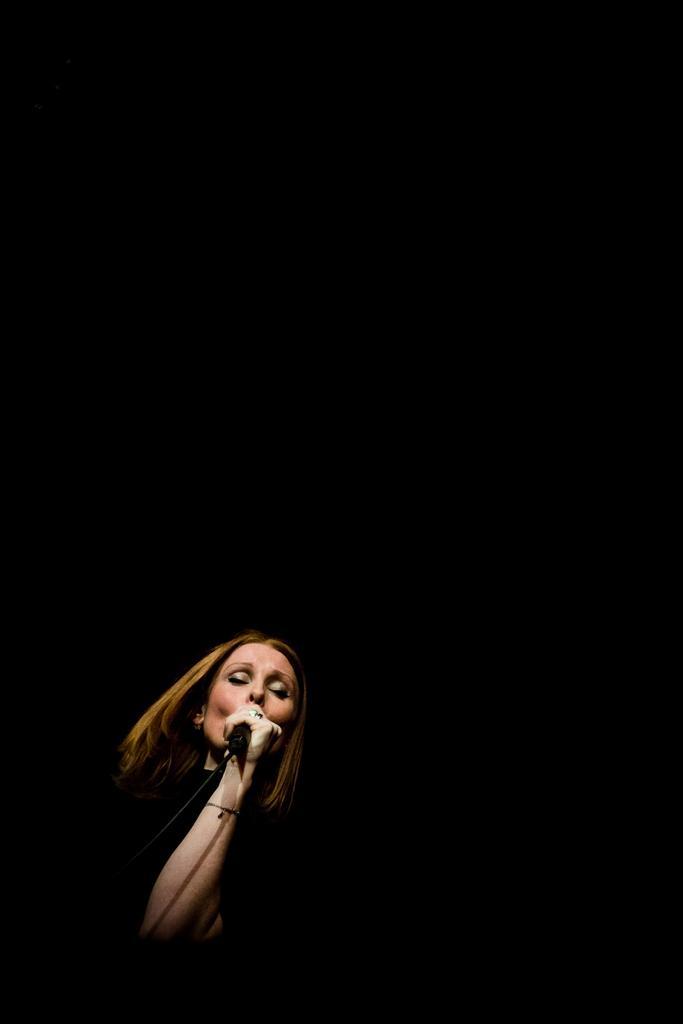Could you give a brief overview of what you see in this image? In the foreground there is a woman holding a mic and singing. The background and at the top it is dark. 